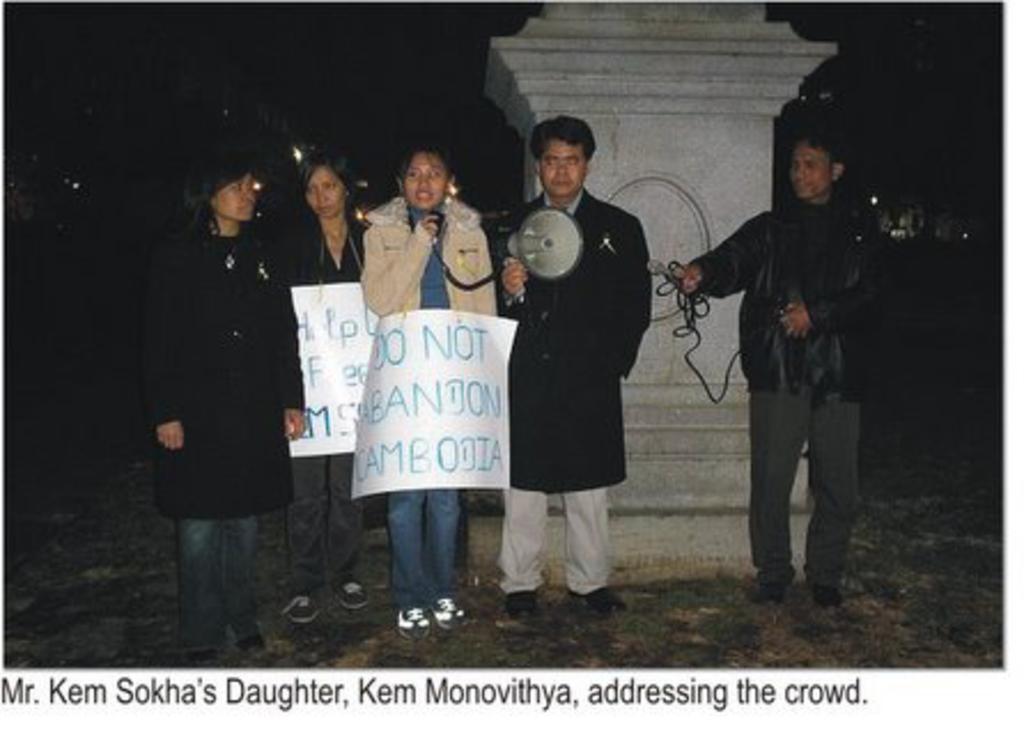Could you give a brief overview of what you see in this image? In this image I see 3 women and 2 men and I see that there are 2 papers over here and I see few words written on it and I see that this man is holding a megaphone in his hand and I see that this man is holding wires and I see the white thing over here and it is dark in the background and I see few words written over here too. 